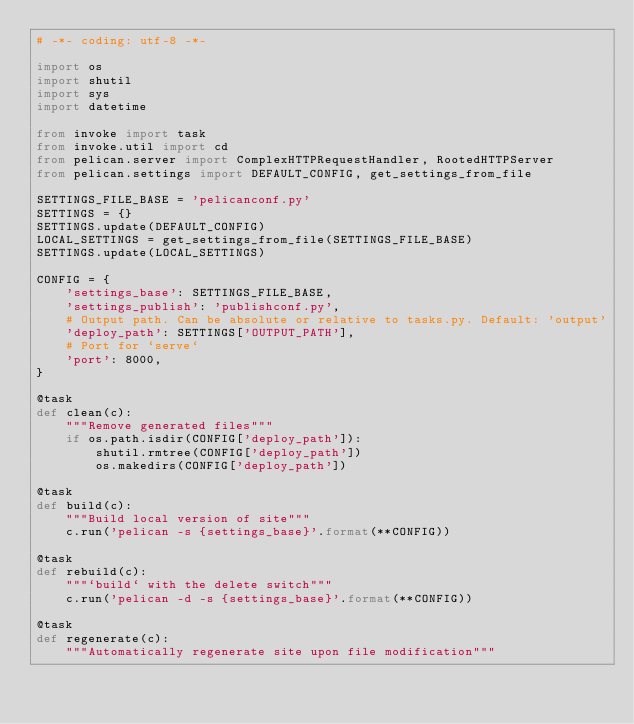<code> <loc_0><loc_0><loc_500><loc_500><_Python_># -*- coding: utf-8 -*-

import os
import shutil
import sys
import datetime

from invoke import task
from invoke.util import cd
from pelican.server import ComplexHTTPRequestHandler, RootedHTTPServer
from pelican.settings import DEFAULT_CONFIG, get_settings_from_file

SETTINGS_FILE_BASE = 'pelicanconf.py'
SETTINGS = {}
SETTINGS.update(DEFAULT_CONFIG)
LOCAL_SETTINGS = get_settings_from_file(SETTINGS_FILE_BASE)
SETTINGS.update(LOCAL_SETTINGS)

CONFIG = {
    'settings_base': SETTINGS_FILE_BASE,
    'settings_publish': 'publishconf.py',
    # Output path. Can be absolute or relative to tasks.py. Default: 'output'
    'deploy_path': SETTINGS['OUTPUT_PATH'],
    # Port for `serve`
    'port': 8000,
}

@task
def clean(c):
    """Remove generated files"""
    if os.path.isdir(CONFIG['deploy_path']):
        shutil.rmtree(CONFIG['deploy_path'])
        os.makedirs(CONFIG['deploy_path'])

@task
def build(c):
    """Build local version of site"""
    c.run('pelican -s {settings_base}'.format(**CONFIG))

@task
def rebuild(c):
    """`build` with the delete switch"""
    c.run('pelican -d -s {settings_base}'.format(**CONFIG))

@task
def regenerate(c):
    """Automatically regenerate site upon file modification"""</code> 